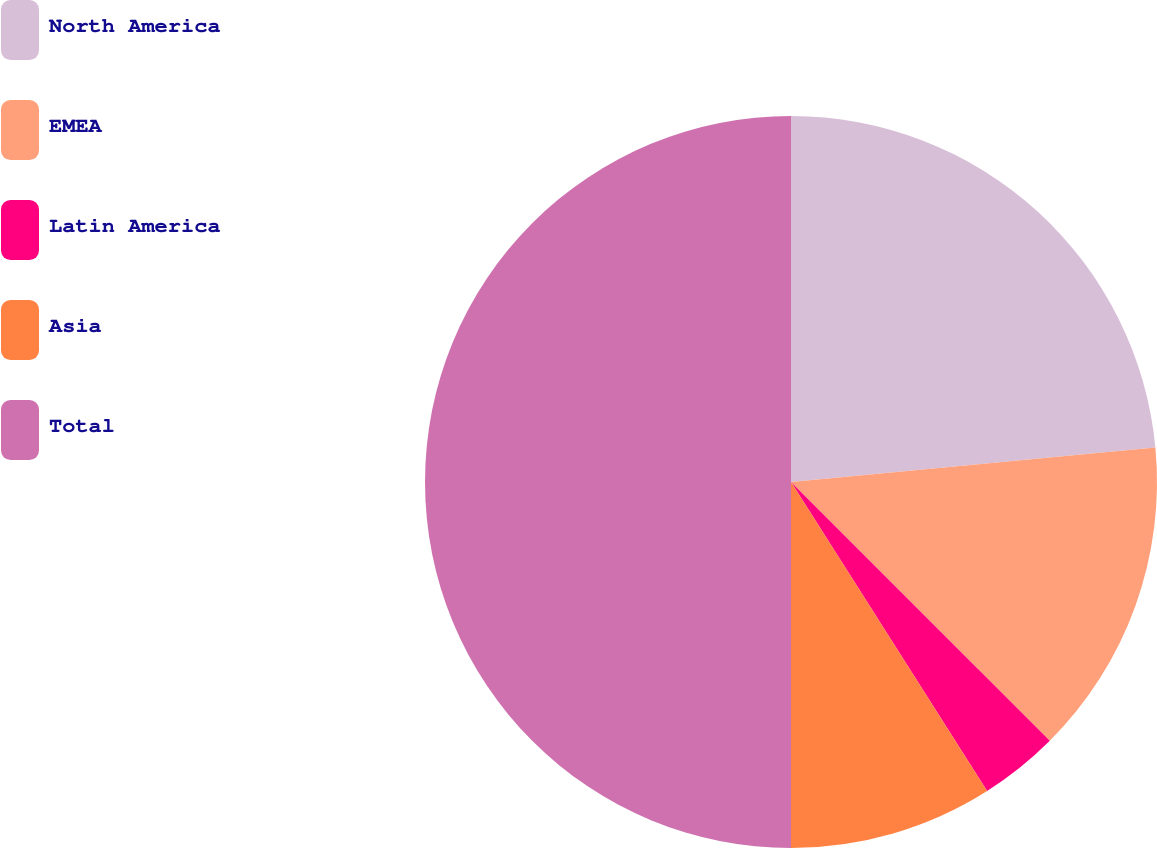Convert chart. <chart><loc_0><loc_0><loc_500><loc_500><pie_chart><fcel>North America<fcel>EMEA<fcel>Latin America<fcel>Asia<fcel>Total<nl><fcel>23.5%<fcel>14.0%<fcel>3.5%<fcel>9.0%<fcel>50.0%<nl></chart> 